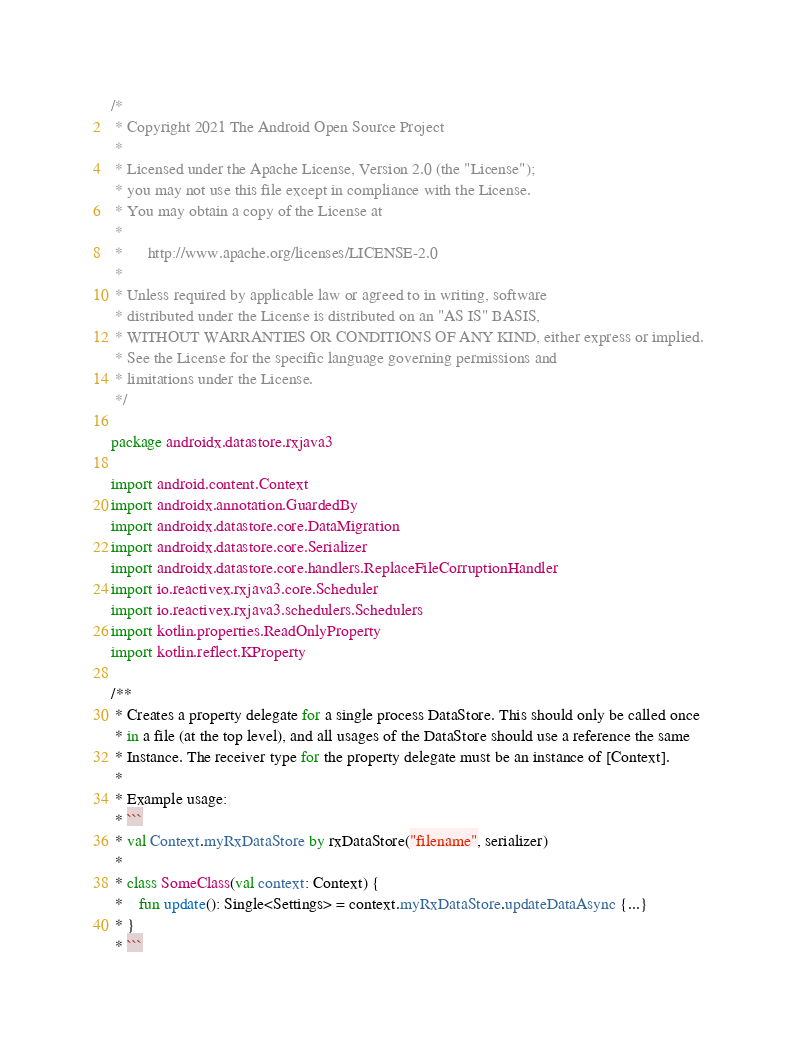<code> <loc_0><loc_0><loc_500><loc_500><_Kotlin_>/*
 * Copyright 2021 The Android Open Source Project
 *
 * Licensed under the Apache License, Version 2.0 (the "License");
 * you may not use this file except in compliance with the License.
 * You may obtain a copy of the License at
 *
 *      http://www.apache.org/licenses/LICENSE-2.0
 *
 * Unless required by applicable law or agreed to in writing, software
 * distributed under the License is distributed on an "AS IS" BASIS,
 * WITHOUT WARRANTIES OR CONDITIONS OF ANY KIND, either express or implied.
 * See the License for the specific language governing permissions and
 * limitations under the License.
 */

package androidx.datastore.rxjava3

import android.content.Context
import androidx.annotation.GuardedBy
import androidx.datastore.core.DataMigration
import androidx.datastore.core.Serializer
import androidx.datastore.core.handlers.ReplaceFileCorruptionHandler
import io.reactivex.rxjava3.core.Scheduler
import io.reactivex.rxjava3.schedulers.Schedulers
import kotlin.properties.ReadOnlyProperty
import kotlin.reflect.KProperty

/**
 * Creates a property delegate for a single process DataStore. This should only be called once
 * in a file (at the top level), and all usages of the DataStore should use a reference the same
 * Instance. The receiver type for the property delegate must be an instance of [Context].
 *
 * Example usage:
 * ```
 * val Context.myRxDataStore by rxDataStore("filename", serializer)
 *
 * class SomeClass(val context: Context) {
 *    fun update(): Single<Settings> = context.myRxDataStore.updateDataAsync {...}
 * }
 * ```</code> 